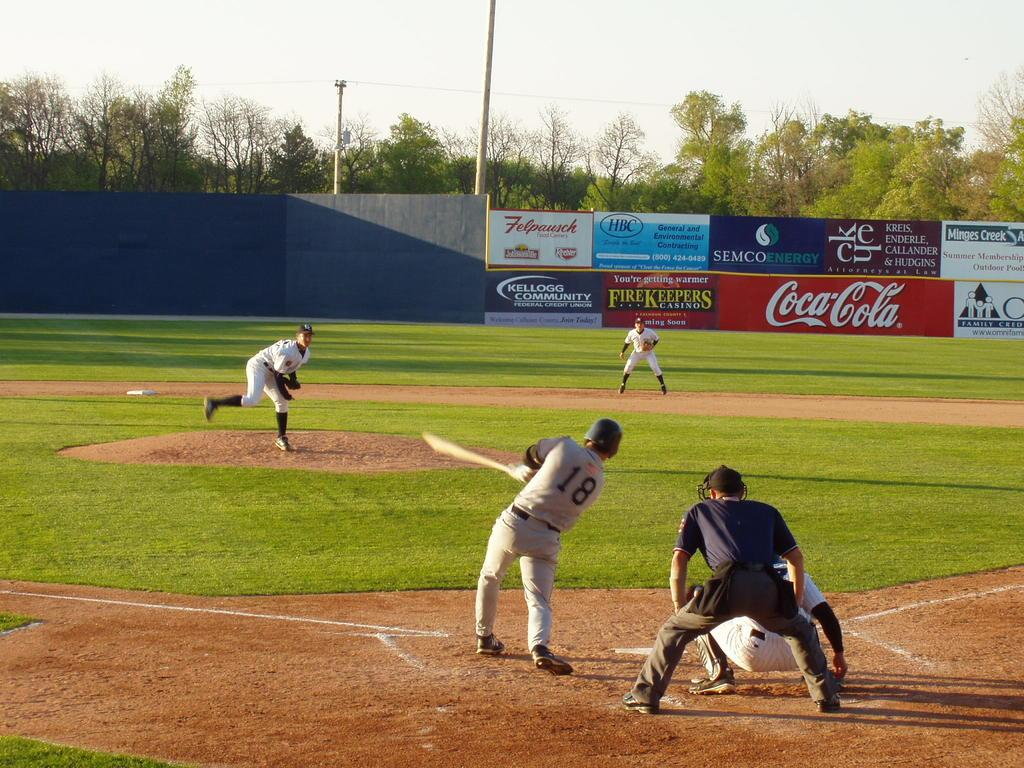<image>
Offer a succinct explanation of the picture presented. Baseball park with a sponsor board by Coca-Cola 